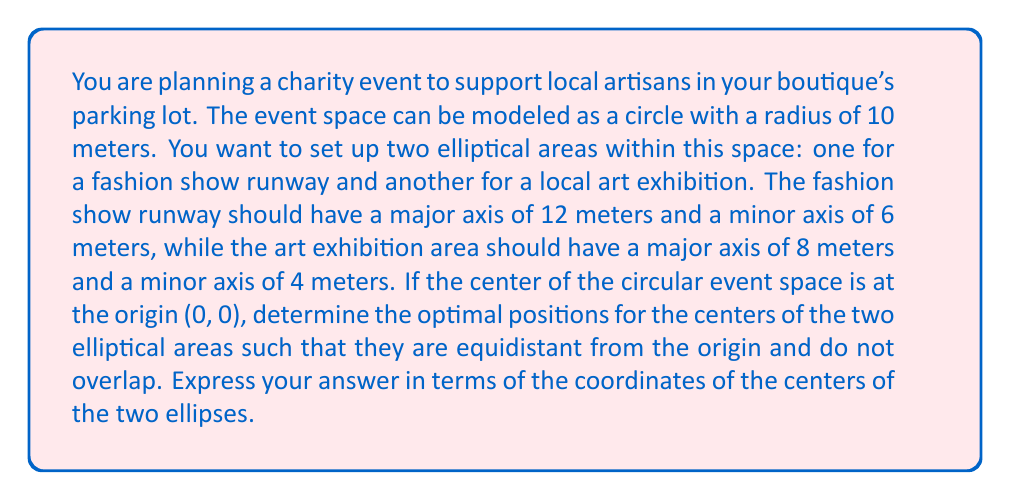Provide a solution to this math problem. Let's approach this problem step by step:

1) First, we need to understand the constraints:
   - The circular event space has a radius of 10 meters and is centered at (0, 0).
   - The fashion show runway ellipse has a major axis of 12m and a minor axis of 6m.
   - The art exhibition ellipse has a major axis of 8m and a minor axis of 4m.
   - The ellipses should be equidistant from the origin and should not overlap.

2) Let's denote the center of the fashion show ellipse as $(x_1, y_1)$ and the art exhibition ellipse as $(x_2, y_2)$.

3) Given that they are equidistant from the origin, we can say:
   $$x_1^2 + y_1^2 = x_2^2 + y_2^2 = d^2$$
   where $d$ is the distance from the origin to the center of each ellipse.

4) To ensure the ellipses don't overlap, we need to position them on opposite sides of the origin. A simple way to do this is to place them along the x-axis:
   $(x_1, y_1) = (d, 0)$ and $(x_2, y_2) = (-d, 0)$

5) Now, we need to determine the value of $d$. To do this, we need to ensure that the ellipses fit within the circular space without overlapping.

6) The equation of an ellipse centered at $(h, k)$ with semi-major axis $a$ and semi-minor axis $b$ is:
   $$\frac{(x-h)^2}{a^2} + \frac{(y-k)^2}{b^2} = 1$$

7) For the fashion show ellipse:
   $$\frac{(x-d)^2}{6^2} + \frac{y^2}{3^2} = 1$$

8) For the art exhibition ellipse:
   $$\frac{(x+d)^2}{4^2} + \frac{y^2}{2^2} = 1$$

9) To fit within the circular space, the rightmost point of the fashion show ellipse should be at x = 10:
   $d + 6 = 10$
   $d = 4$

10) We need to verify that this placement doesn't cause overlap. The leftmost point of the fashion show ellipse is at $x = 4 - 6 = -2$, while the rightmost point of the art exhibition ellipse is at $x = -4 + 4 = 0$. These don't overlap.

11) Finally, we need to check if the art exhibition ellipse fits within the circular space. Its leftmost point is at $x = -4 - 4 = -8$, which is within the circular space.

Therefore, the optimal positions for the centers of the two ellipses are (4, 0) for the fashion show runway and (-4, 0) for the art exhibition area.
Answer: The optimal positions for the centers of the two elliptical areas are (4, 0) for the fashion show runway and (-4, 0) for the art exhibition area. 